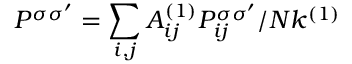Convert formula to latex. <formula><loc_0><loc_0><loc_500><loc_500>P ^ { \sigma \sigma ^ { \prime } } = \sum _ { i , j } A _ { i j } ^ { ( 1 ) } P _ { i j } ^ { \sigma \sigma ^ { \prime } } / N k ^ { ( 1 ) }</formula> 